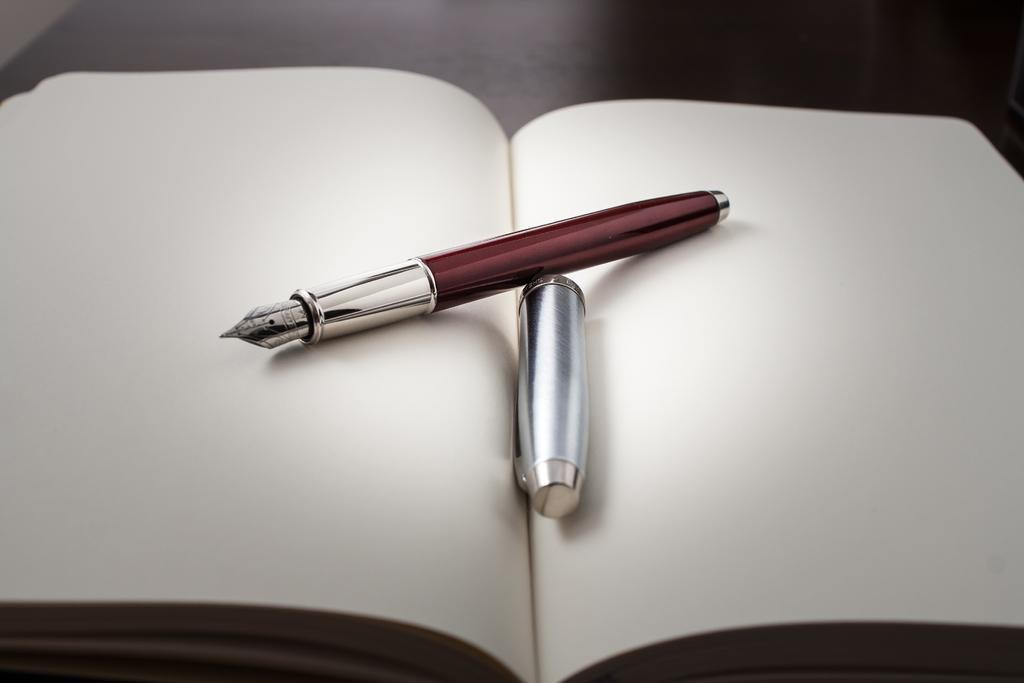In one or two sentences, can you explain what this image depicts? In this picture there is a book on the table and there is a pen and cap on the book. 